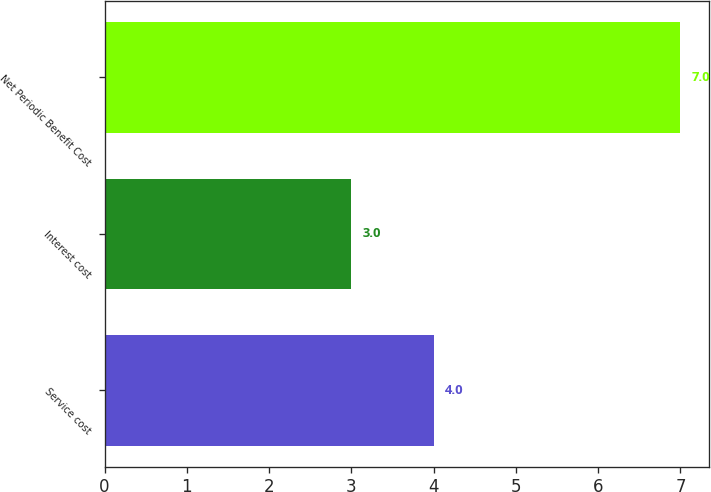Convert chart to OTSL. <chart><loc_0><loc_0><loc_500><loc_500><bar_chart><fcel>Service cost<fcel>Interest cost<fcel>Net Periodic Benefit Cost<nl><fcel>4<fcel>3<fcel>7<nl></chart> 